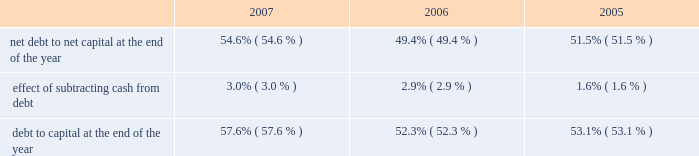E nt e r g y c o r p o r a t i o n a n d s u b s i d i a r i e s 2 0 0 7 n an increase of $ 16 million in fossil operating costs due to the purchase of the attala plant in january 2006 and the perryville plant coming online in july 2005 ; n an increase of $ 12 million related to storm reserves .
This increase does not include costs associated with hurricanes katrina and rita ; and n an increase of $ 12 million due to a return to normal expense patterns in 2006 versus the deferral or capitalization of storm costs in 2005 .
Other operation and maintenance expenses increased for non- utility nuclear from $ 588 million in 2005 to $ 637 million in 2006 primarily due to the timing of refueling outages , increased benefit and insurance costs , and increased nrc fees .
Taxes other than income taxes taxes other than income taxes increased for the utility from $ 322 million in 2005 to $ 361 million in 2006 primarily due to an increase in city franchise taxes in arkansas due to a change in 2006 in the accounting for city franchise tax revenues as directed by the apsc .
The change results in an increase in taxes other than income taxes with a corresponding increase in rider revenue , resulting in no effect on net income .
Also contributing to the increase was higher franchise tax expense at entergy gulf states , inc .
As a result of higher gross revenues in 2006 and a customer refund in 2005 .
Other income other income increased for the utility from $ 111 million in 2005 to $ 156 million in 2006 primarily due to carrying charges recorded on storm restoration costs .
Other income increased for non-utility nuclear primarily due to miscellaneous income of $ 27 million ( $ 16.6 million net-of-tax ) resulting from a reduction in the decommissioning liability for a plant as a result of a revised decommissioning cost study and changes in assumptions regarding the timing of when decommissioning of a plant will begin .
Other income increased for parent & other primarily due to a gain related to its entergy-koch investment of approximately $ 55 million ( net-of-tax ) in the fourth quarter of 2006 .
In 2004 , entergy-koch sold its energy trading and pipeline businesses to third parties .
At that time , entergy received $ 862 million of the sales proceeds in the form of a cash distribution by entergy-koch .
Due to the november 2006 expiration of contingencies on the sale of entergy-koch 2019s trading business , and the corresponding release to entergy-koch of sales proceeds held in escrow , entergy received additional cash distributions of approximately $ 163 million during the fourth quarter of 2006 and recorded a gain of approximately $ 55 million ( net-of-tax ) .
Entergy expects future cash distributions upon liquidation of the partnership will be less than $ 35 million .
Interest charges interest charges increased for the utility and parent & other primarily due to additional borrowing to fund the significant storm restoration costs associated with hurricanes katrina and rita .
Discontinued operations in april 2006 , entergy sold the retail electric portion of the competitive retail services business operating in the electric reliability council of texas ( ercot ) region of texas , and now reports this portion of the business as a discontinued operation .
Earnings for 2005 were negatively affected by $ 44.8 million ( net-of-tax ) of discontinued operations due to the planned sale .
This amount includes a net charge of $ 25.8 million ( net-of-tax ) related to the impairment reserve for the remaining net book value of the competitive retail services business 2019 information technology systems .
Results for 2006 include an $ 11.1 million gain ( net-of-tax ) on the sale of the retail electric portion of the competitive retail services business operating in the ercot region of texas .
Income taxes the effective income tax rates for 2006 and 2005 were 27.6% ( 27.6 % ) and 36.6% ( 36.6 % ) , respectively .
The lower effective income tax rate in 2006 is primarily due to tax benefits , net of reserves , resulting from the tax capital loss recognized in connection with the liquidation of entergy power international holdings , entergy 2019s holding company for entergy-koch .
Also contributing to the lower rate for 2006 is an irs audit settlement that allowed entergy to release from its tax reserves all settled issues relating to 1996-1998 audit cycle .
See note 3 to the financial statements for a reconciliation of the federal statutory rate of 35.0% ( 35.0 % ) to the effective income tax rates , and for additional discussion regarding income taxes .
Liquidity and capital resources this section discusses entergy 2019s capital structure , capital spending plans and other uses of capital , sources of capital , and the cash flow activity presented in the cash flow statement .
Capital structure entergy 2019s capitalization is balanced between equity and debt , as shown in the table .
The increase in the debt to capital percentage from 2006 to 2007 is primarily the result of additional borrowings under entergy corporation 2019s revolving credit facility , along with a decrease in shareholders 2019 equity primarily due to repurchases of common stock .
This increase in the debt to capital percentage is in line with entergy 2019s financial and risk management aspirations .
The decrease in the debt to capital percentage from 2005 to 2006 is the result of an increase in shareholders 2019 equity , primarily due to an increase in retained earnings , partially offset by repurchases of common stock. .
Net debt consists of debt less cash and cash equivalents .
Debt consists of notes payable , capital lease obligations , preferred stock with sinking fund , and long-term debt , including the currently maturing portion .
Capital consists of debt , shareholders 2019 equity , and preferred stock without sinking fund .
Net capital consists of capital less cash and cash equivalents .
Entergy uses the net debt to net capital ratio in analyzing its financial condition and believes it provides useful information to its investors and creditors in evaluating entergy 2019s financial condition .
M an ag e ment 2019s f i n anc ial d i scuss ion an d an alys is co n t i n u e d .
What is the change in percentage points in cash-to-debt ratio from 2005 to 2006? 
Computations: (2.9 - 1.6)
Answer: 1.3. 